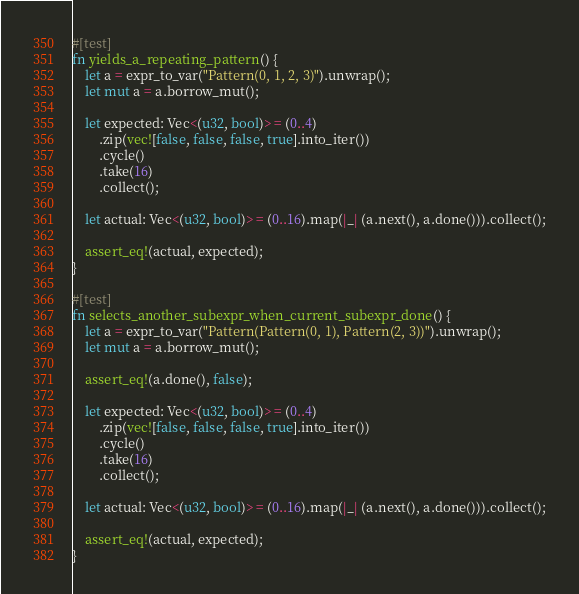<code> <loc_0><loc_0><loc_500><loc_500><_Rust_>#[test]
fn yields_a_repeating_pattern() {
    let a = expr_to_var("Pattern(0, 1, 2, 3)").unwrap();
    let mut a = a.borrow_mut();

    let expected: Vec<(u32, bool)> = (0..4)
        .zip(vec![false, false, false, true].into_iter())
        .cycle()
        .take(16)
        .collect();

    let actual: Vec<(u32, bool)> = (0..16).map(|_| (a.next(), a.done())).collect();

    assert_eq!(actual, expected);
}

#[test]
fn selects_another_subexpr_when_current_subexpr_done() {
    let a = expr_to_var("Pattern(Pattern(0, 1), Pattern(2, 3))").unwrap();
    let mut a = a.borrow_mut();

    assert_eq!(a.done(), false);

    let expected: Vec<(u32, bool)> = (0..4)
        .zip(vec![false, false, false, true].into_iter())
        .cycle()
        .take(16)
        .collect();

    let actual: Vec<(u32, bool)> = (0..16).map(|_| (a.next(), a.done())).collect();

    assert_eq!(actual, expected);
}
</code> 